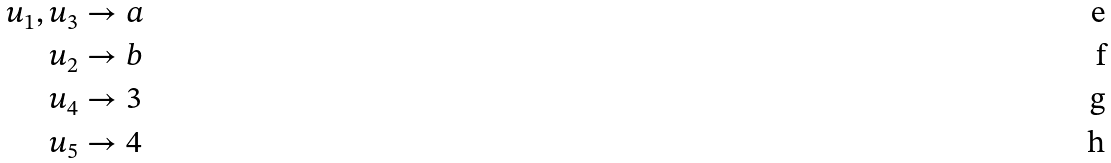Convert formula to latex. <formula><loc_0><loc_0><loc_500><loc_500>u _ { 1 } , u _ { 3 } & \to a \\ u _ { 2 } & \to b \\ u _ { 4 } & \to 3 \\ u _ { 5 } & \to 4</formula> 